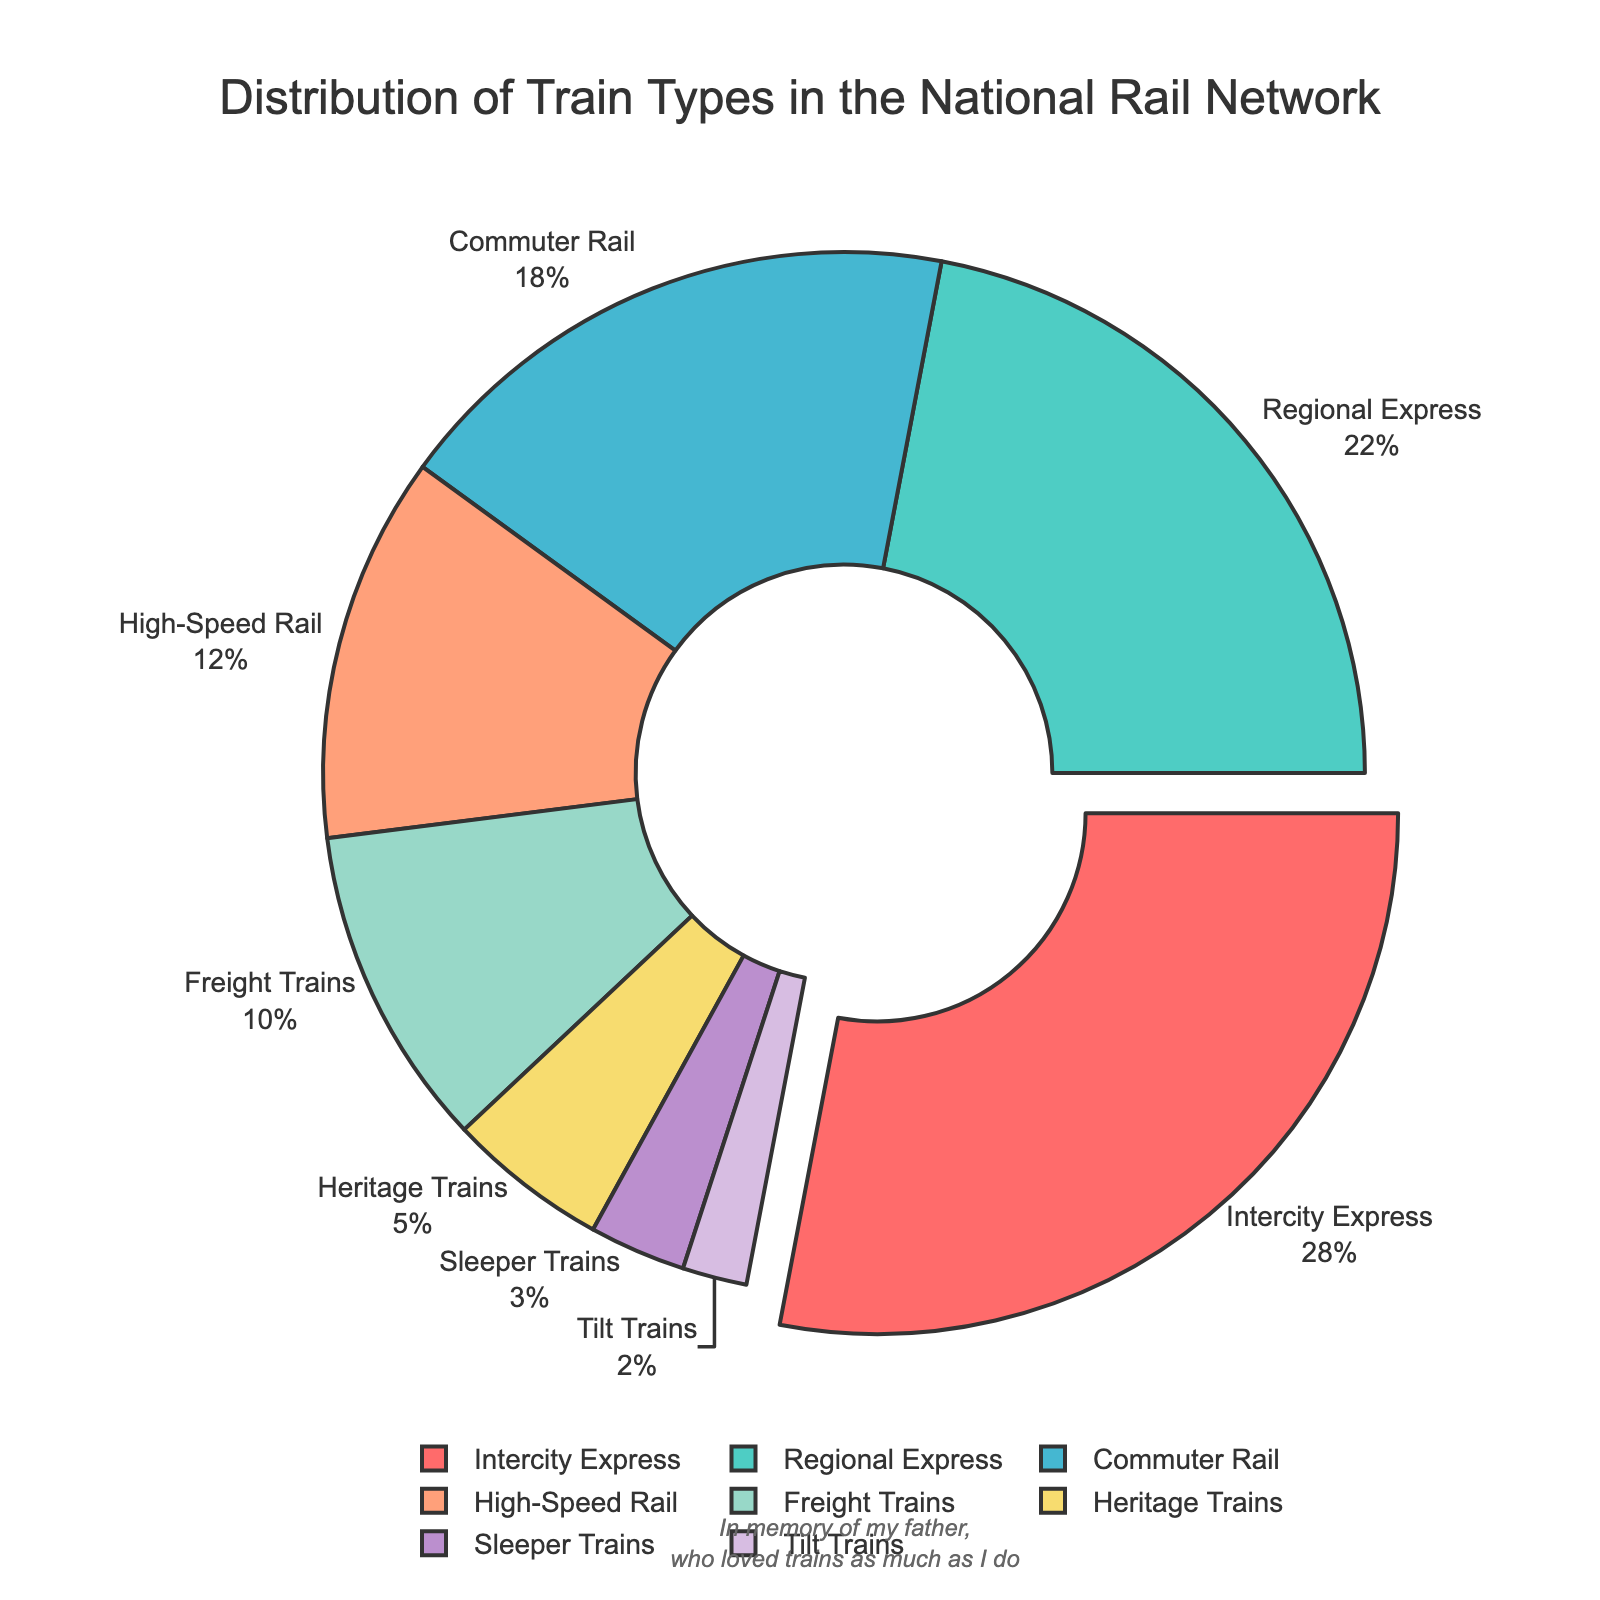Which train type has the highest percentage in the national rail network? Looking at the pie chart, observe which segment is the largest. The largest segment corresponds to the Intercity Express trains.
Answer: Intercity Express What is the combined percentage of Freight Trains and Heritage Trains? Identify the individual percentages of Freight Trains and Heritage Trains from the pie chart (10% and 5% respectively) and sum them up: 10 + 5 = 15
Answer: 15% By how much does the percentage of Regional Express trains exceed that of Commuter Rail trains? Identify the individual percentages of Regional Express and Commuter Rail trains (22% and 18% respectively) and find their difference: 22 - 18 = 4
Answer: 4% Which train types together make up more than half of the total distribution? Add the percentages of the largest contributing train types until you exceed 50%. Intercity Express (28%) + Regional Express (22%) = 50%, but adding another type like Commuter Rail (18%) far exceeds 50%.
Answer: Intercity Express, Regional Express, Commuter Rail What is the average percentage of High-Speed Rail, Sleeper Trains, and Tilt Trains? Identify the individual percentages (12%, 3%, and 2% respectively), sum them up: 12 + 3 + 2 = 17, then divide by the number of categories: 17 / 3 ≈ 5.67
Answer: 5.67 Which train type is represented by the smallest segment in the pie chart, and what is its percentage? Identify the smallest segment visually from the pie chart, which corresponds to Tilt Trains at 2%.
Answer: Tilt Trains, 2% How does the percentage of Sleeper Trains compare to that of Heritage Trains? Identify the individual percentages (3% for Sleeper Trains and 5% for Heritage Trains) and compare them. Sleeper Trains have a smaller percentage than Heritage Trains.
Answer: Sleeper Trains have a smaller percentage If you were to group Commuter Rail, High-Speed Rail, and Sleeper Trains together, what would their combined percentage be? Add the individual percentages of Commuter Rail (18%), High-Speed Rail (12%), and Sleeper Trains (3%): 18 + 12 + 3 = 33
Answer: 33% Which two train types have the closest percentage values and what are those values? Look for segments in the pie chart with similar sizes. Commuter Rail (18%) and High-Speed Rail (12%) are the closest in value.
Answer: Commuter Rail (18%), High-Speed Rail (12%) What visual attribute makes the Intercity Express segment stand out in the pie chart? Observe the visual differentiations used in the chart. The Intercity Express segment is pulled out slightly from the center, making it stand out.
Answer: It is pulled out slightly 